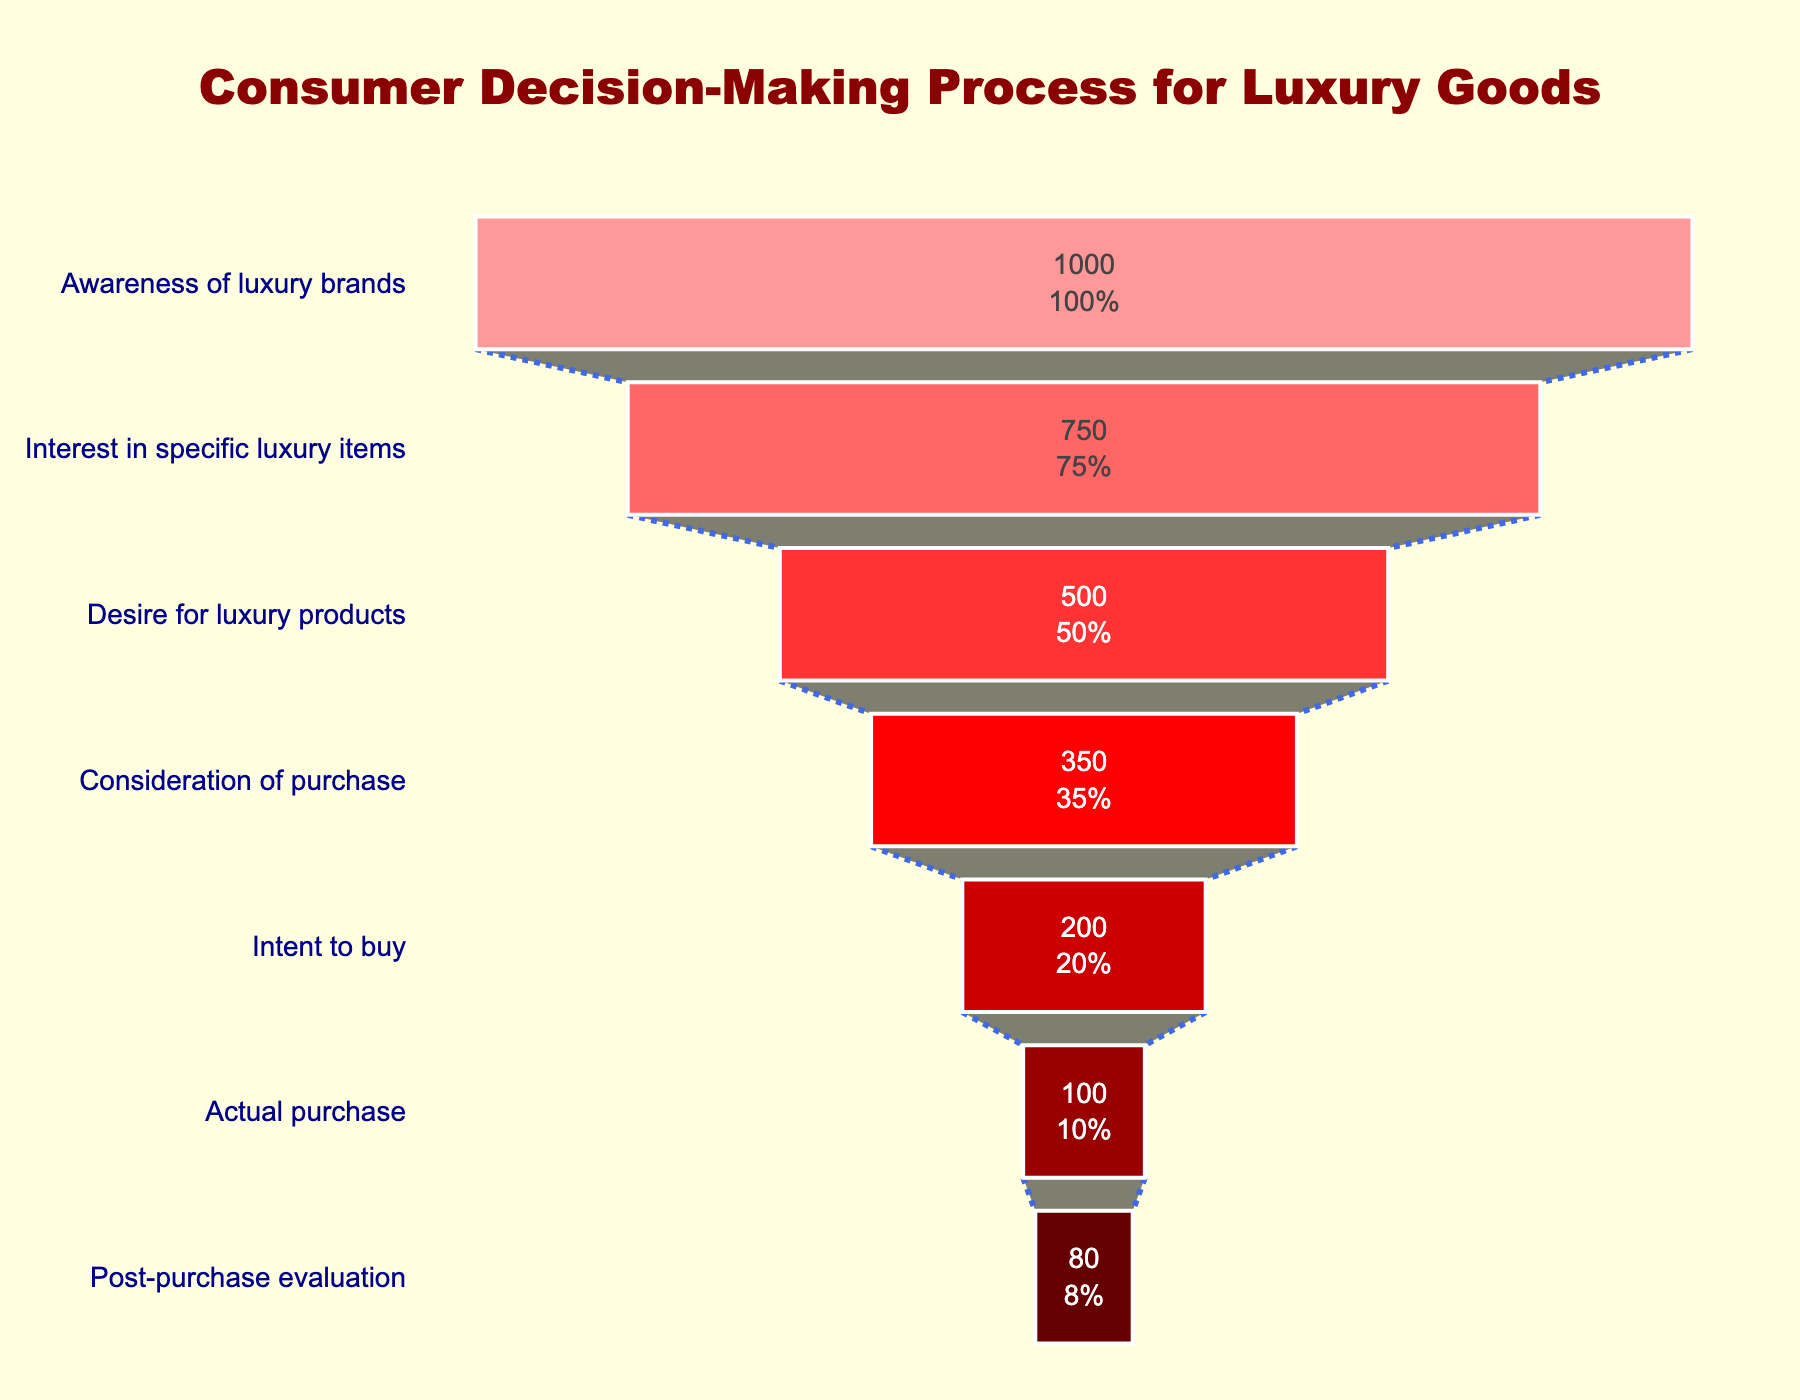What is the title of the funnel chart? The title of the funnel chart is prominently displayed at the top in large, bold, dark red font.
Answer: Consumer Decision-Making Process for Luxury Goods How many stages are there in the consumer decision-making process as shown in the chart? There are seven distinct stages of the consumer decision-making process depicted in the funnel chart.
Answer: 7 What is the number of consumers at the "Interest in specific luxury items" stage? To answer this, look at the horizontal bars corresponding to each stage and find the value for the "Interest in specific luxury items" stage.
Answer: 750 By how much does the number of consumers decrease from the "Intent to buy" stage to the "Actual purchase" stage? Subtract the number of consumers at the "Actual purchase" stage from the number of consumers at the "Intent to buy" stage. Calculation: 200 - 100 = 100
Answer: 100 Which stage has the smallest number of consumers? By observing the number of consumers for each stage, identify the stage with the lowest value. The "Post-purchase evaluation" stage has the smallest number of consumers.
Answer: Post-purchase evaluation What percentage of the initial consumers remain in the "Consideration of purchase" stage? This involves calculating the proportion of consumers at the "Consideration of purchase" stage relative to the initial number of consumers and expressing it as a percentage. Calculation: (350 / 1000) * 100 = 35%
Answer: 35% How does the reduction in consumers from "Desire for luxury products" to "Consideration of purchase" compare with the reduction from "Interest in specific luxury items" to "Desire for luxury products"? Calculate the drop in consumer numbers for both transitions: "Desire for luxury products" to "Consideration of purchase" is 500 - 350 = 150; "Interest in specific luxury items" to "Desire for luxury products" is 750 - 500 = 250. Then, compare 150 and 250.
Answer: The reduction from "Interest in specific luxury items" to "Desire for luxury products" is larger What is the combined number of consumers at the "Actual purchase" and "Post-purchase evaluation" stages? Add the number of consumers at the "Actual purchase" stage to the number of consumers at the "Post-purchase evaluation" stage. Calculation: 100 + 80 = 180
Answer: 180 What color is used to represent the "Awareness of luxury brands" stage? The color for each stage is visually distinct. The color for the "Awareness of luxury brands" stage is a shade of light red or pink.
Answer: Light red/pink 